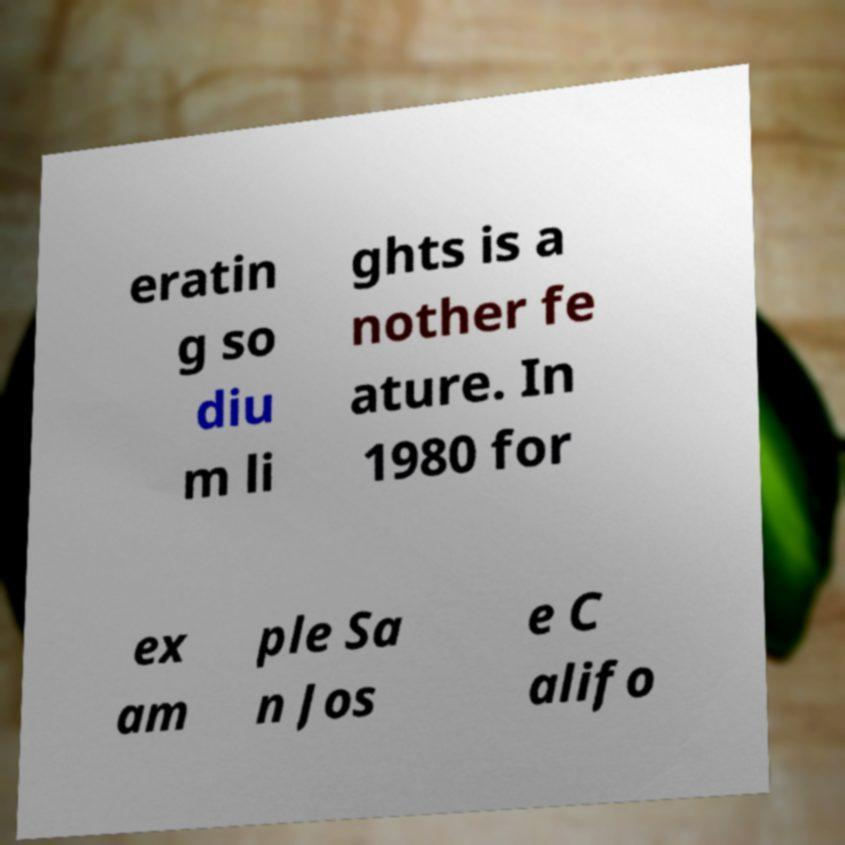Please identify and transcribe the text found in this image. eratin g so diu m li ghts is a nother fe ature. In 1980 for ex am ple Sa n Jos e C alifo 